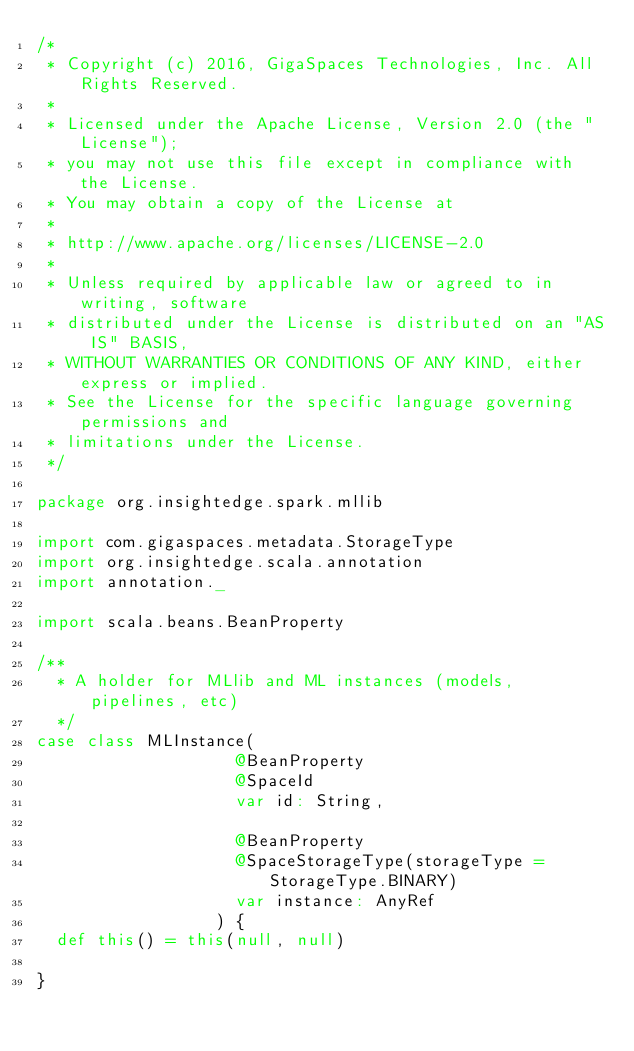<code> <loc_0><loc_0><loc_500><loc_500><_Scala_>/*
 * Copyright (c) 2016, GigaSpaces Technologies, Inc. All Rights Reserved.
 *
 * Licensed under the Apache License, Version 2.0 (the "License");
 * you may not use this file except in compliance with the License.
 * You may obtain a copy of the License at
 *
 * http://www.apache.org/licenses/LICENSE-2.0
 *
 * Unless required by applicable law or agreed to in writing, software
 * distributed under the License is distributed on an "AS IS" BASIS,
 * WITHOUT WARRANTIES OR CONDITIONS OF ANY KIND, either express or implied.
 * See the License for the specific language governing permissions and
 * limitations under the License.
 */

package org.insightedge.spark.mllib

import com.gigaspaces.metadata.StorageType
import org.insightedge.scala.annotation
import annotation._

import scala.beans.BeanProperty

/**
  * A holder for MLlib and ML instances (models, pipelines, etc)
  */
case class MLInstance(
                    @BeanProperty
                    @SpaceId
                    var id: String,

                    @BeanProperty
                    @SpaceStorageType(storageType = StorageType.BINARY)
                    var instance: AnyRef
                  ) {
  def this() = this(null, null)

}
</code> 